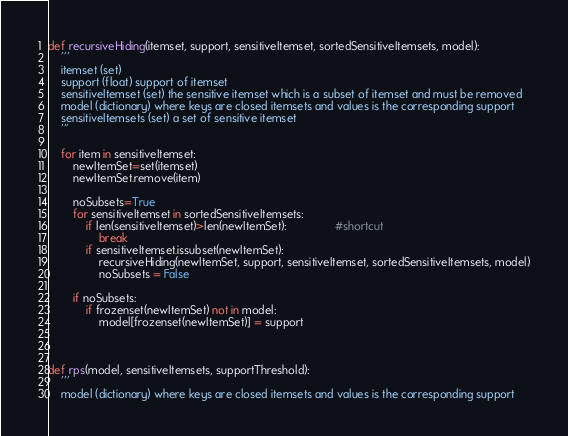Convert code to text. <code><loc_0><loc_0><loc_500><loc_500><_Python_>def recursiveHiding(itemset, support, sensitiveItemset, sortedSensitiveItemsets, model):
    '''
    itemset (set)
    support (float) support of itemset
    sensitiveItemset (set) the sensitive itemset which is a subset of itemset and must be removed
    model (dictionary) where keys are closed itemsets and values is the corresponding support
    sensitiveItemsets (set) a set of sensitive itemset
    '''
    
    for item in sensitiveItemset:           
        newItemSet=set(itemset)
        newItemSet.remove(item)        
                                        
        noSubsets=True
        for sensitiveItemset in sortedSensitiveItemsets: 
            if len(sensitiveItemset)>len(newItemSet):               #shortcut
                break
            if sensitiveItemset.issubset(newItemSet):
                recursiveHiding(newItemSet, support, sensitiveItemset, sortedSensitiveItemsets, model)
                noSubsets = False

        if noSubsets:
            if frozenset(newItemSet) not in model:
                model[frozenset(newItemSet)] = support



def rps(model, sensitiveItemsets, supportThreshold):
    '''
    model (dictionary) where keys are closed itemsets and values is the corresponding support</code> 